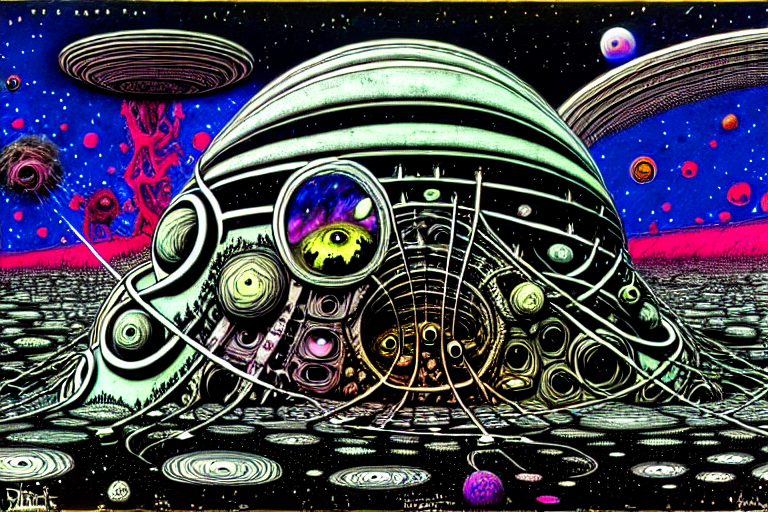Is the overall clarity of the image excellent?
A. No
B. Yes
Answer with the option's letter from the given choices directly.
 B. 